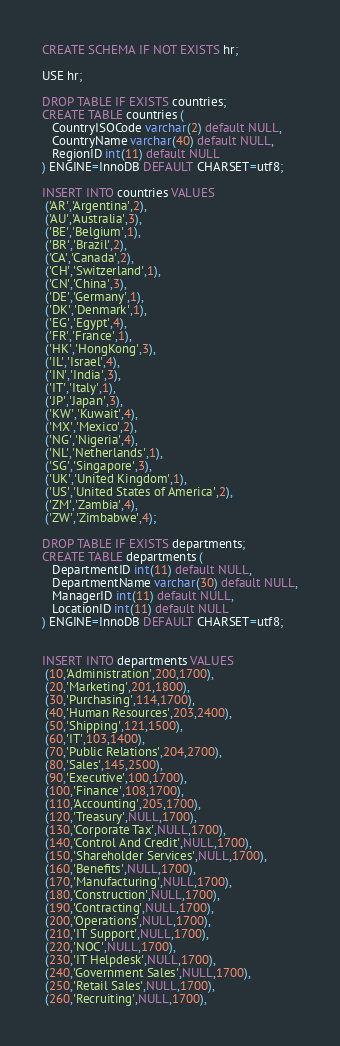Convert code to text. <code><loc_0><loc_0><loc_500><loc_500><_SQL_>CREATE SCHEMA IF NOT EXISTS hr;

USE hr;

DROP TABLE IF EXISTS countries;
CREATE TABLE countries (
   CountryISOCode varchar(2) default NULL,
   CountryName varchar(40) default NULL,
   RegionID int(11) default NULL
) ENGINE=InnoDB DEFAULT CHARSET=utf8;

INSERT INTO countries VALUES 
 ('AR','Argentina',2),
 ('AU','Australia',3),
 ('BE','Belgium',1),
 ('BR','Brazil',2),
 ('CA','Canada',2),
 ('CH','Switzerland',1),
 ('CN','China',3),
 ('DE','Germany',1),
 ('DK','Denmark',1),
 ('EG','Egypt',4),
 ('FR','France',1),
 ('HK','HongKong',3),
 ('IL','Israel',4),
 ('IN','India',3),
 ('IT','Italy',1),
 ('JP','Japan',3),
 ('KW','Kuwait',4),
 ('MX','Mexico',2),
 ('NG','Nigeria',4),
 ('NL','Netherlands',1),
 ('SG','Singapore',3),
 ('UK','United Kingdom',1),
 ('US','United States of America',2),
 ('ZM','Zambia',4),
 ('ZW','Zimbabwe',4);

DROP TABLE IF EXISTS departments;
CREATE TABLE departments (
   DepartmentID int(11) default NULL,
   DepartmentName varchar(30) default NULL,
   ManagerID int(11) default NULL,
   LocationID int(11) default NULL
) ENGINE=InnoDB DEFAULT CHARSET=utf8;


INSERT INTO departments VALUES 
 (10,'Administration',200,1700),
 (20,'Marketing',201,1800),
 (30,'Purchasing',114,1700),
 (40,'Human Resources',203,2400),
 (50,'Shipping',121,1500),
 (60,'IT',103,1400),
 (70,'Public Relations',204,2700),
 (80,'Sales',145,2500),
 (90,'Executive',100,1700),
 (100,'Finance',108,1700),
 (110,'Accounting',205,1700),
 (120,'Treasury',NULL,1700),
 (130,'Corporate Tax',NULL,1700),
 (140,'Control And Credit',NULL,1700),
 (150,'Shareholder Services',NULL,1700),
 (160,'Benefits',NULL,1700),
 (170,'Manufacturing',NULL,1700),
 (180,'Construction',NULL,1700),
 (190,'Contracting',NULL,1700),
 (200,'Operations',NULL,1700),
 (210,'IT Support',NULL,1700),
 (220,'NOC',NULL,1700),
 (230,'IT Helpdesk',NULL,1700),
 (240,'Government Sales',NULL,1700),
 (250,'Retail Sales',NULL,1700),
 (260,'Recruiting',NULL,1700),</code> 